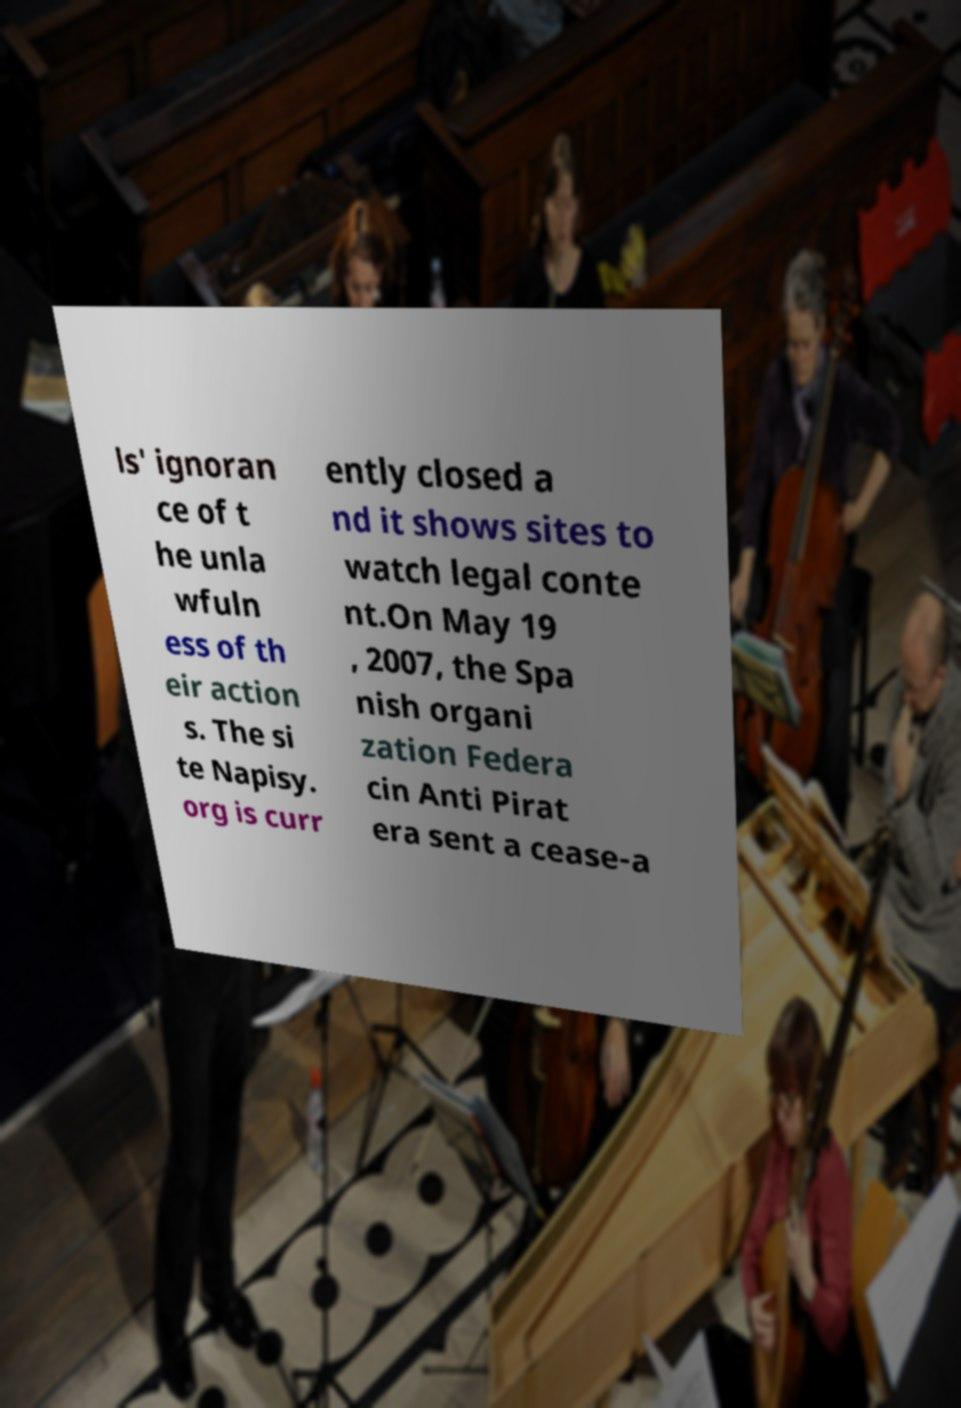What messages or text are displayed in this image? I need them in a readable, typed format. ls' ignoran ce of t he unla wfuln ess of th eir action s. The si te Napisy. org is curr ently closed a nd it shows sites to watch legal conte nt.On May 19 , 2007, the Spa nish organi zation Federa cin Anti Pirat era sent a cease-a 